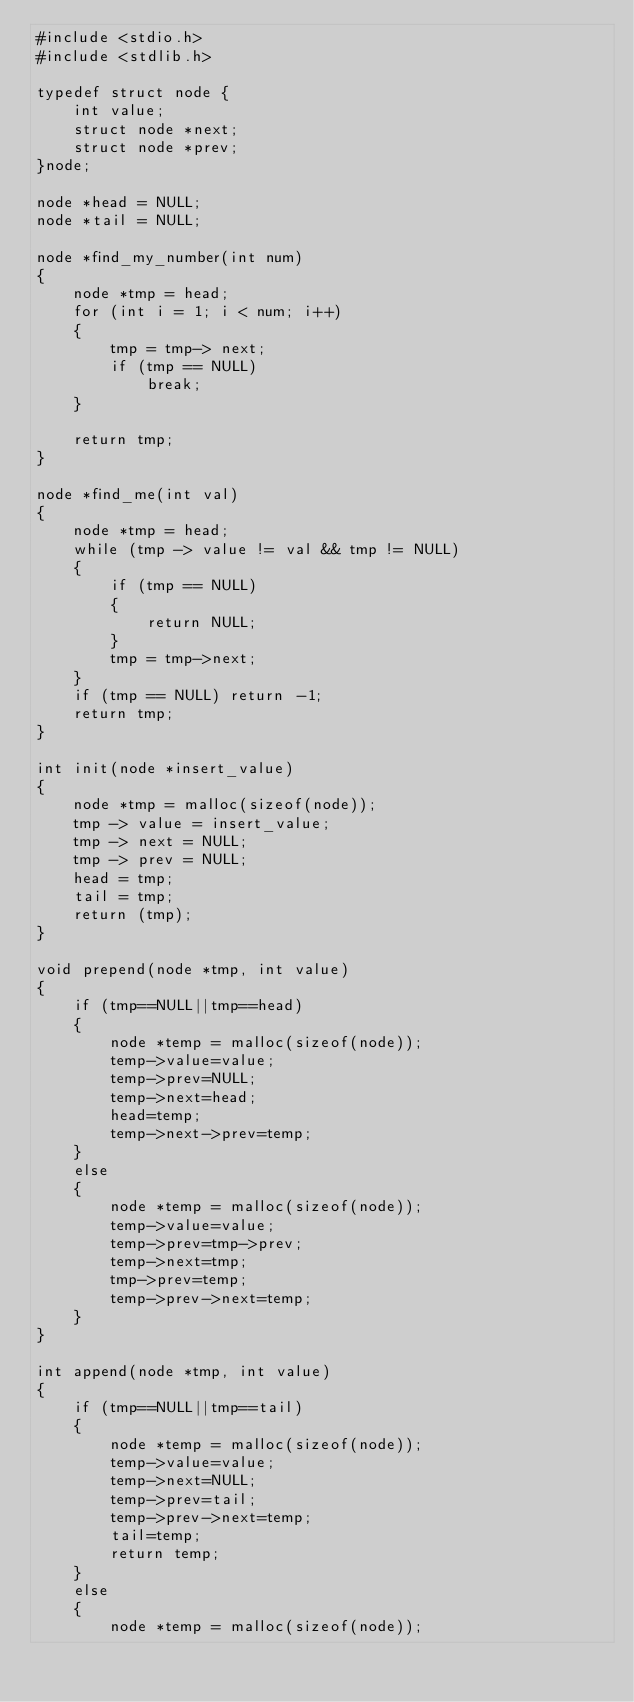Convert code to text. <code><loc_0><loc_0><loc_500><loc_500><_C_>#include <stdio.h>
#include <stdlib.h>

typedef struct node {
    int value;
    struct node *next;
    struct node *prev;
}node;

node *head = NULL;
node *tail = NULL;

node *find_my_number(int num)
{
    node *tmp = head;
    for (int i = 1; i < num; i++)
    {
        tmp = tmp-> next;
        if (tmp == NULL)
            break;
    }

    return tmp;
}

node *find_me(int val)
{
    node *tmp = head;
    while (tmp -> value != val && tmp != NULL)
    {
        if (tmp == NULL)
        {
            return NULL;
        }
        tmp = tmp->next;
    }
    if (tmp == NULL) return -1;
    return tmp;
}

int init(node *insert_value)
{
    node *tmp = malloc(sizeof(node));
    tmp -> value = insert_value;
    tmp -> next = NULL;
    tmp -> prev = NULL;
    head = tmp;
    tail = tmp;
    return (tmp);
}

void prepend(node *tmp, int value)
{
    if (tmp==NULL||tmp==head)
    {
        node *temp = malloc(sizeof(node));
        temp->value=value;
        temp->prev=NULL;
        temp->next=head;
        head=temp;
        temp->next->prev=temp;
    }
    else
    {
        node *temp = malloc(sizeof(node));
        temp->value=value;
        temp->prev=tmp->prev;
        temp->next=tmp;
        tmp->prev=temp;
        temp->prev->next=temp;
    }
}

int append(node *tmp, int value)
{
    if (tmp==NULL||tmp==tail)
    {
        node *temp = malloc(sizeof(node));
        temp->value=value;
        temp->next=NULL;
        temp->prev=tail;
        temp->prev->next=temp;
        tail=temp;
        return temp;
    }
    else
    {
        node *temp = malloc(sizeof(node));</code> 